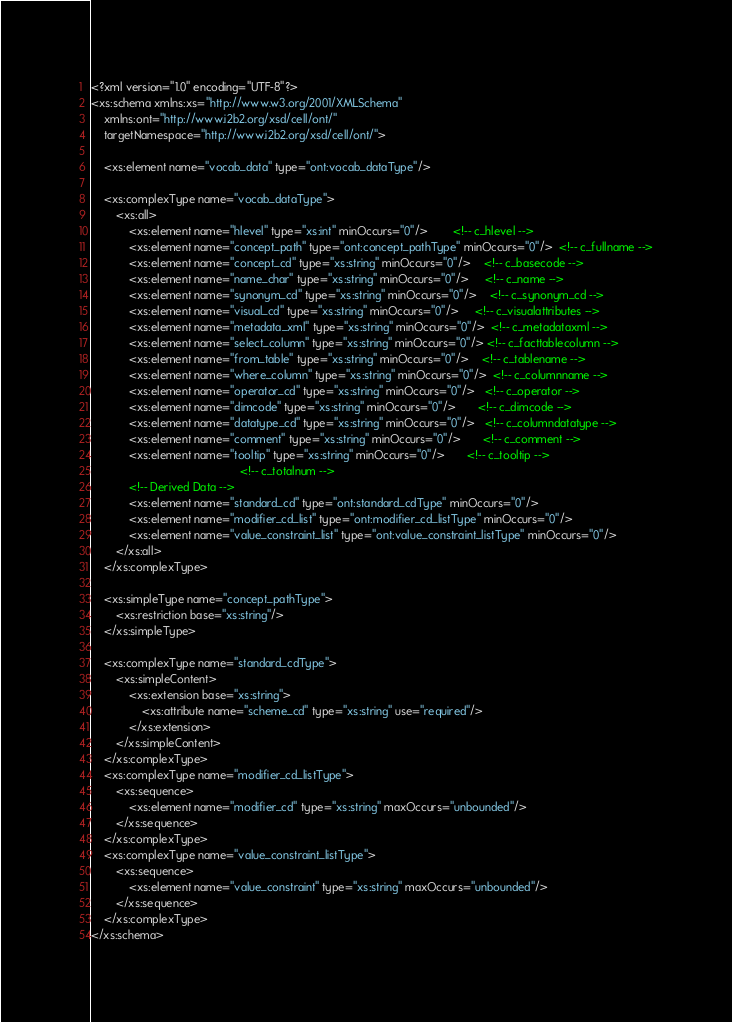<code> <loc_0><loc_0><loc_500><loc_500><_XML_><?xml version="1.0" encoding="UTF-8"?>
<xs:schema xmlns:xs="http://www.w3.org/2001/XMLSchema"
    xmlns:ont="http://www.i2b2.org/xsd/cell/ont/"
    targetNamespace="http://www.i2b2.org/xsd/cell/ont/">
    
    <xs:element name="vocab_data" type="ont:vocab_dataType"/>
    
    <xs:complexType name="vocab_dataType">
        <xs:all>
            <xs:element name="hlevel" type="xs:int" minOccurs="0"/>        <!-- c_hlevel -->
            <xs:element name="concept_path" type="ont:concept_pathType" minOccurs="0"/>  <!-- c_fullname -->
            <xs:element name="concept_cd" type="xs:string" minOccurs="0"/>    <!-- c_basecode -->
            <xs:element name="name_char" type="xs:string" minOccurs="0"/>     <!-- c_name -->
            <xs:element name="synonym_cd" type="xs:string" minOccurs="0"/>    <!-- c_synonym_cd -->
            <xs:element name="visual_cd" type="xs:string" minOccurs="0"/>     <!-- c_visualattributes -->
            <xs:element name="metadata_xml" type="xs:string" minOccurs="0"/>  <!-- c_metadataxml -->
            <xs:element name="select_column" type="xs:string" minOccurs="0"/> <!-- c_facttablecolumn -->
            <xs:element name="from_table" type="xs:string" minOccurs="0"/>    <!-- c_tablename -->
            <xs:element name="where_column" type="xs:string" minOccurs="0"/>  <!-- c_columnname -->
            <xs:element name="operator_cd" type="xs:string" minOccurs="0"/>   <!-- c_operator -->
            <xs:element name="dimcode" type="xs:string" minOccurs="0"/>       <!-- c_dimcode -->
            <xs:element name="datatype_cd" type="xs:string" minOccurs="0"/>   <!-- c_columndatatype -->
            <xs:element name="comment" type="xs:string" minOccurs="0"/>       <!-- c_comment -->
            <xs:element name="tooltip" type="xs:string" minOccurs="0"/>       <!-- c_tooltip -->
                                               <!-- c_totalnum -->
            <!-- Derived Data -->
            <xs:element name="standard_cd" type="ont:standard_cdType" minOccurs="0"/>
            <xs:element name="modifier_cd_list" type="ont:modifier_cd_listType" minOccurs="0"/>
            <xs:element name="value_constraint_list" type="ont:value_constraint_listType" minOccurs="0"/>
        </xs:all>
    </xs:complexType>
    
    <xs:simpleType name="concept_pathType">
        <xs:restriction base="xs:string"/>
    </xs:simpleType>
    
    <xs:complexType name="standard_cdType">
        <xs:simpleContent>
            <xs:extension base="xs:string">
                <xs:attribute name="scheme_cd" type="xs:string" use="required"/>
            </xs:extension>
        </xs:simpleContent>
    </xs:complexType>
    <xs:complexType name="modifier_cd_listType">
        <xs:sequence>
            <xs:element name="modifier_cd" type="xs:string" maxOccurs="unbounded"/>
        </xs:sequence>
    </xs:complexType>
    <xs:complexType name="value_constraint_listType">
        <xs:sequence>
            <xs:element name="value_constraint" type="xs:string" maxOccurs="unbounded"/>
        </xs:sequence>
    </xs:complexType>
</xs:schema>


</code> 